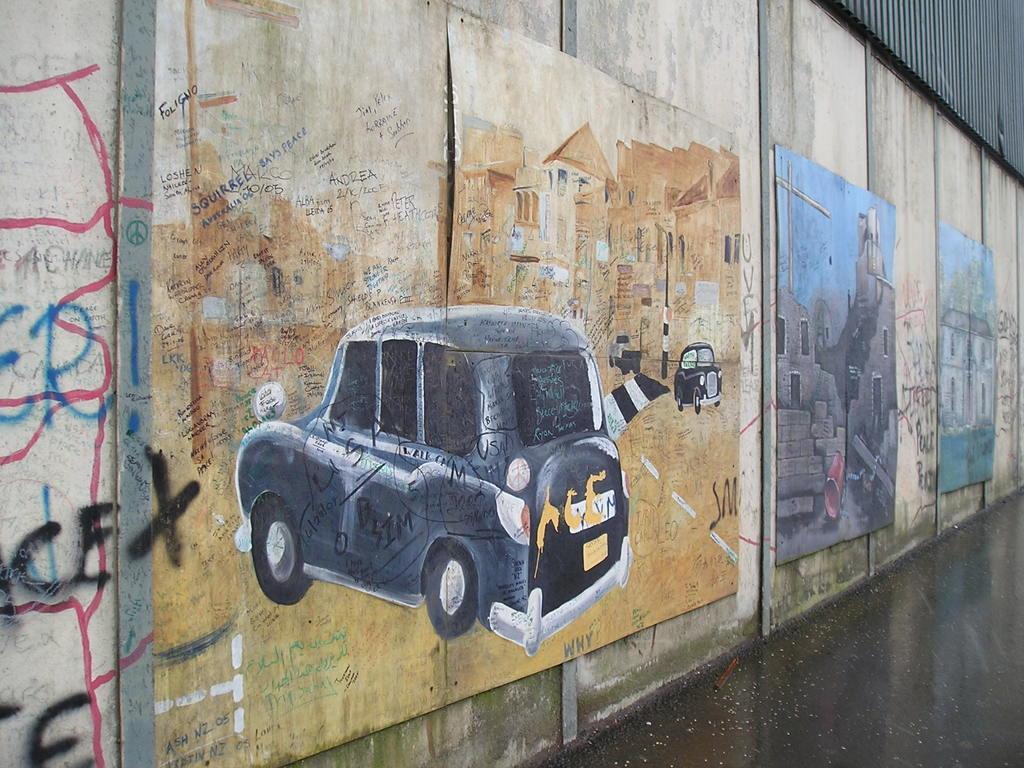Describe this image in one or two sentences. In this picture there are three paintings on the wall. On the right there is a painting which showing car and buildings. Beside that there is another painting which showing the buildings, stairs and sky. At the bottom we can see the road and water. 